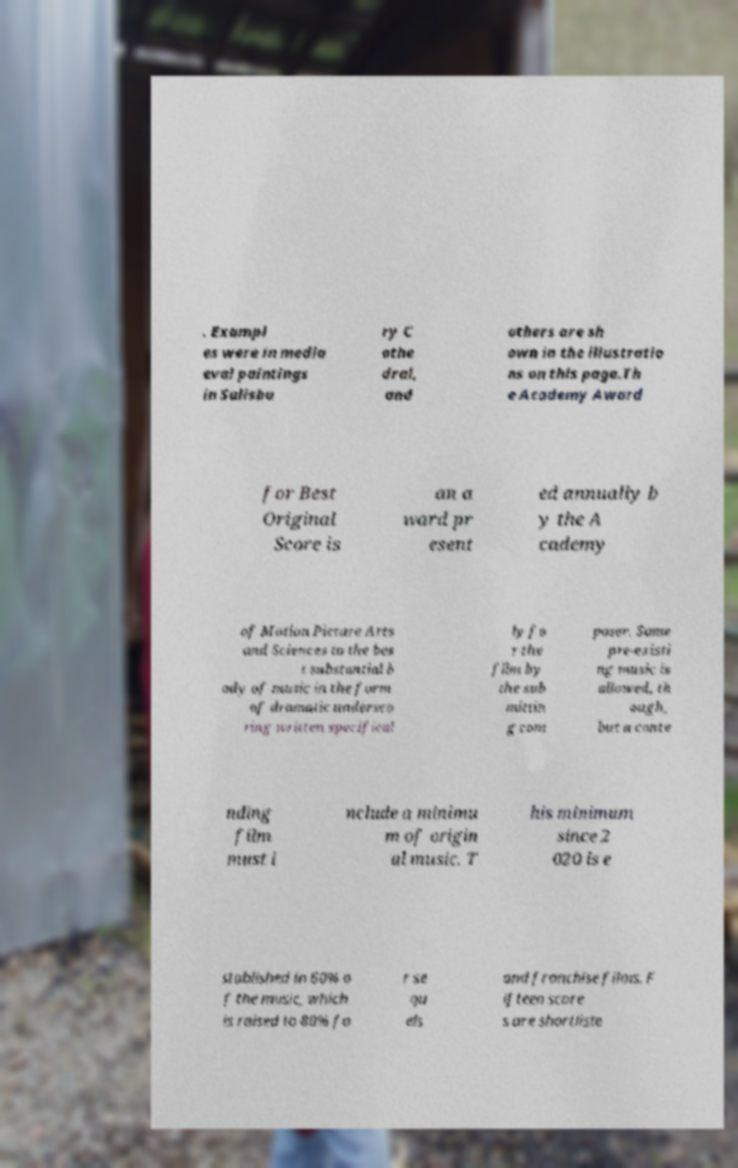There's text embedded in this image that I need extracted. Can you transcribe it verbatim? . Exampl es were in media eval paintings in Salisbu ry C athe dral, and others are sh own in the illustratio ns on this page.Th e Academy Award for Best Original Score is an a ward pr esent ed annually b y the A cademy of Motion Picture Arts and Sciences to the bes t substantial b ody of music in the form of dramatic undersco ring written specifical ly fo r the film by the sub mittin g com poser. Some pre-existi ng music is allowed, th ough, but a conte nding film must i nclude a minimu m of origin al music. T his minimum since 2 020 is e stablished in 60% o f the music, which is raised to 80% fo r se qu els and franchise films. F ifteen score s are shortliste 